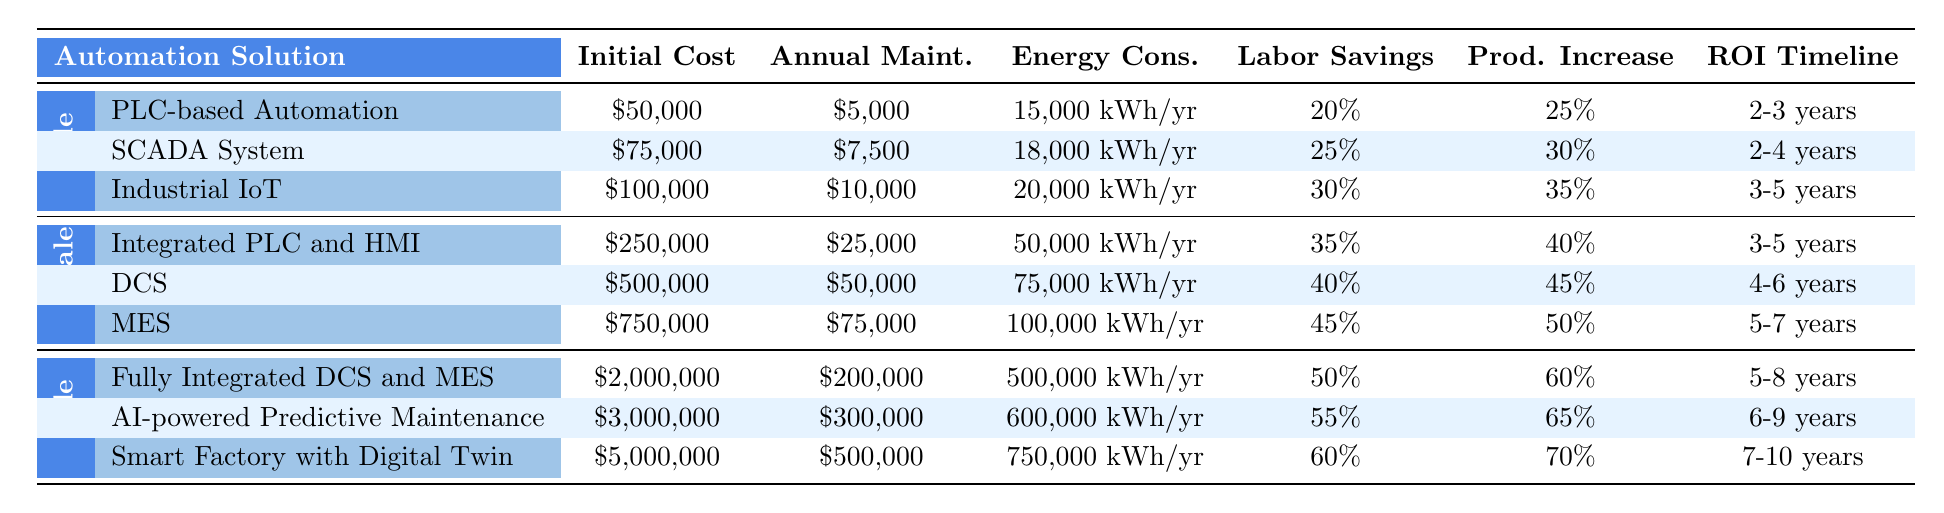What is the initial cost of the SCADA System in a small-scale manufacturing plant? The initial cost of the SCADA System is listed in the table under the Small-scale category. It states that the initial cost is $75,000.
Answer: $75,000 What is the annual maintenance cost for the Industrial IoT solution? The annual maintenance cost for the Industrial IoT solution is found in the Small-scale section of the table, and it is indicated as $10,000.
Answer: $10,000 Which automation solution offers the highest labor savings in large-scale plants? In the Large-scale section of the table, the automation solution with the highest labor savings is the Smart Factory with Digital Twin, which offers 60% labor savings.
Answer: Smart Factory with Digital Twin What is the total initial cost for medium-scale automation solutions? To find the total initial cost for medium-scale automation solutions, sum the initial costs of each solution: $250,000 (Integrated PLC and HMI) + $500,000 (DCS) + $750,000 (MES) = $1,500,000.
Answer: $1,500,000 Which solution type has the longest ROI timeline in small-scale manufacturing? The Industrial IoT has the longest ROI timeline in the Small-scale category, which is noted as 3-5 years.
Answer: Industrial IoT Is the energy consumption of the MES solution in medium-scale manufacturing higher than that of the DCS? The energy consumption for MES is 100,000 kWh/year, while the DCS has an energy consumption of 75,000 kWh/year. Since 100,000 > 75,000, the statement is true.
Answer: Yes What is the average productivity increase for medium-scale automation solutions? The productivity increases for medium-scale solutions are 40% (Integrated PLC and HMI), 45% (DCS), and 50% (MES). Calculate the average by summing these percentages: (40 + 45 + 50) / 3 = 135 / 3 = 45%.
Answer: 45% How does the annual maintenance cost of the AI-powered Predictive Maintenance solution compare to that of the Fully Integrated DCS and MES? The annual maintenance cost for AI-powered Predictive Maintenance is $300,000, and for the Fully Integrated DCS and MES, it is $200,000. The comparison shows that $300,000 is greater than $200,000, indicating that AI-powered Predictive Maintenance has a higher maintenance cost.
Answer: Higher What is the difference in energy consumption between the SCADA System and the Industrial IoT for small-scale plants? The energy consumption for the SCADA System is 18,000 kWh/year and for the Industrial IoT is 20,000 kWh/year. The difference can be calculated as 20,000 - 18,000 = 2,000 kWh/year.
Answer: 2,000 kWh/year Which solution requires the longest ROI timeline in medium-scale manufacturing? The MES (Manufacturing Execution System) requires the longest ROI timeline in the medium-scale category, which is 5-7 years as stated in the table.
Answer: MES 